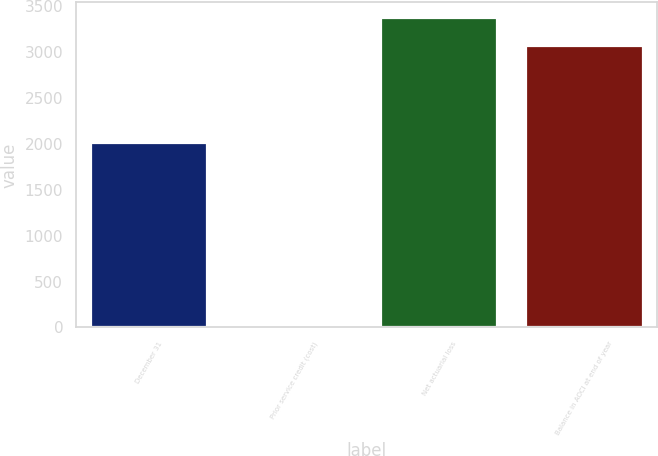Convert chart. <chart><loc_0><loc_0><loc_500><loc_500><bar_chart><fcel>December 31<fcel>Prior service credit (cost)<fcel>Net actuarial loss<fcel>Balance in AOCI at end of year<nl><fcel>2014<fcel>10<fcel>3375.9<fcel>3069<nl></chart> 